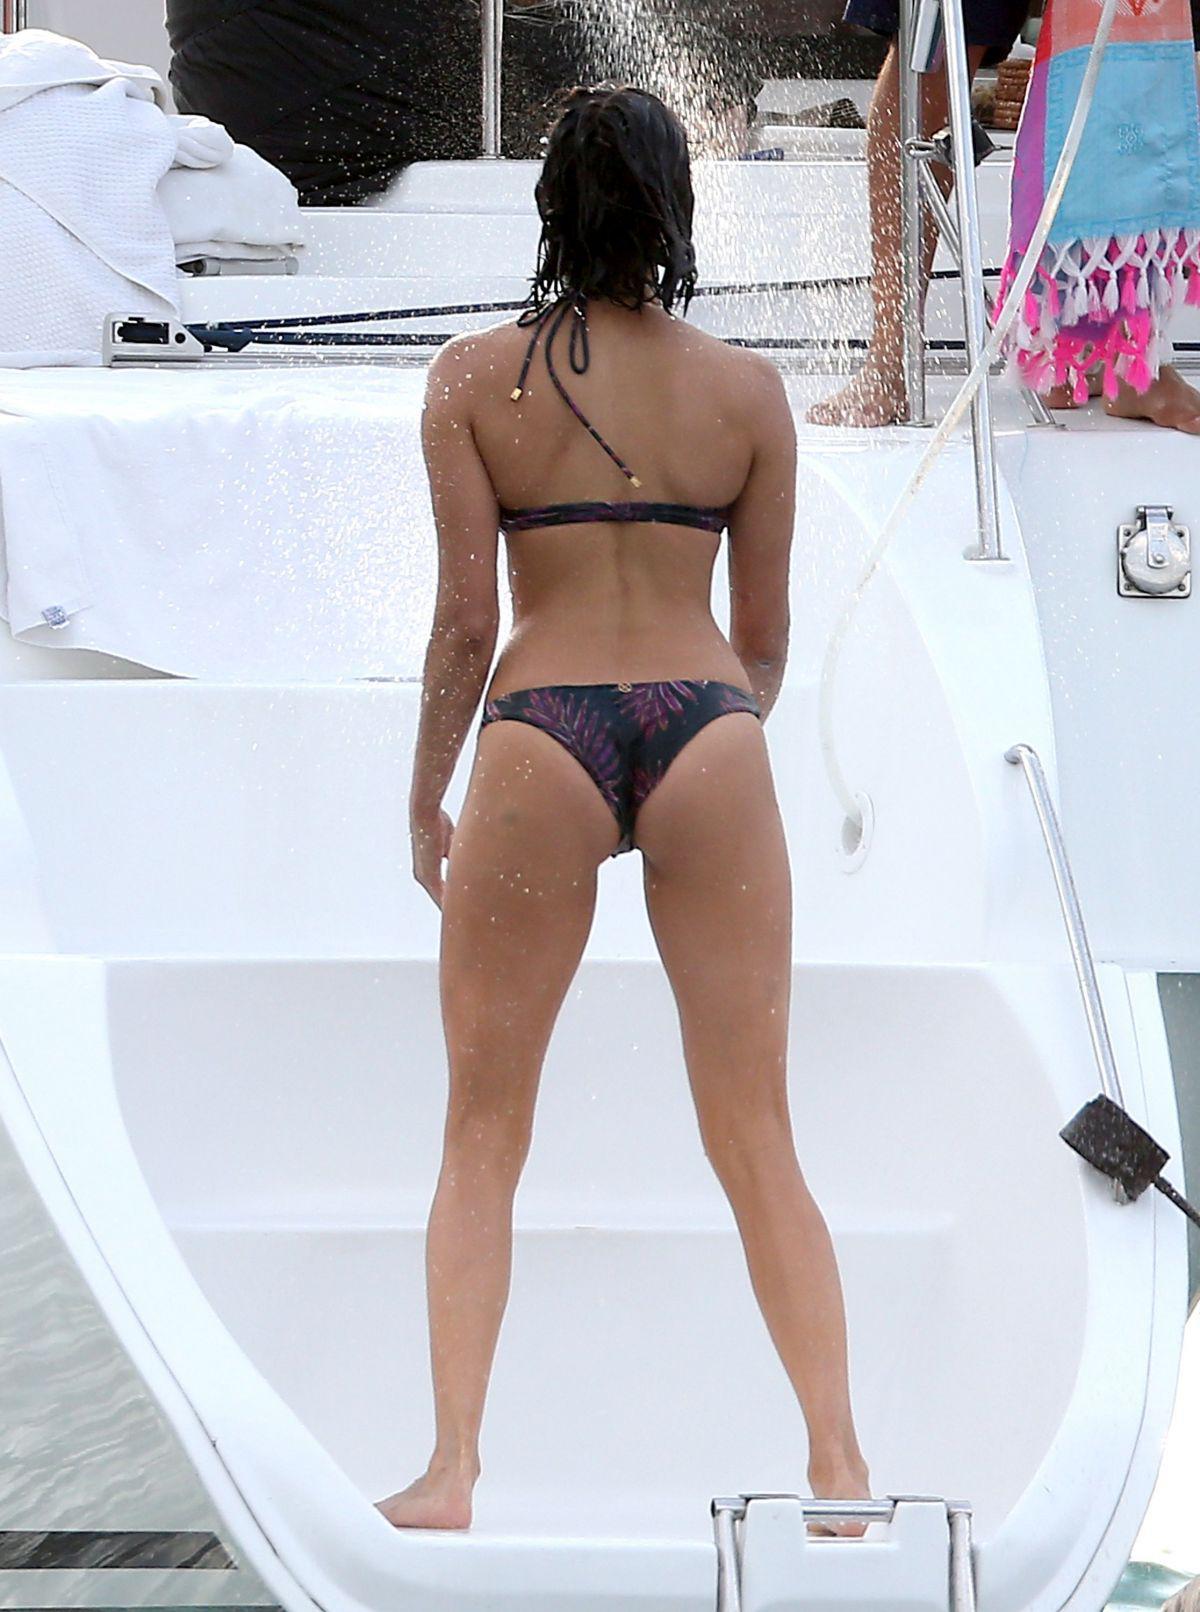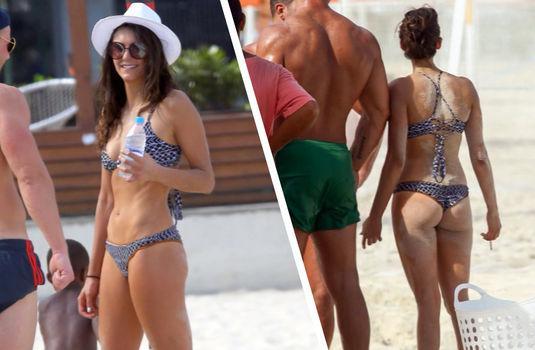The first image is the image on the left, the second image is the image on the right. Examine the images to the left and right. Is the description "The right image shows a woman in a red bikini top and a woman in a blue bikini top looking at a camera together" accurate? Answer yes or no. No. The first image is the image on the left, the second image is the image on the right. Analyze the images presented: Is the assertion "There are two women wearing swimsuits in the image on the left." valid? Answer yes or no. No. 